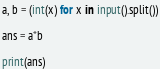Convert code to text. <code><loc_0><loc_0><loc_500><loc_500><_Python_>a, b = (int(x) for x in input().split())

ans = a*b

print(ans)</code> 